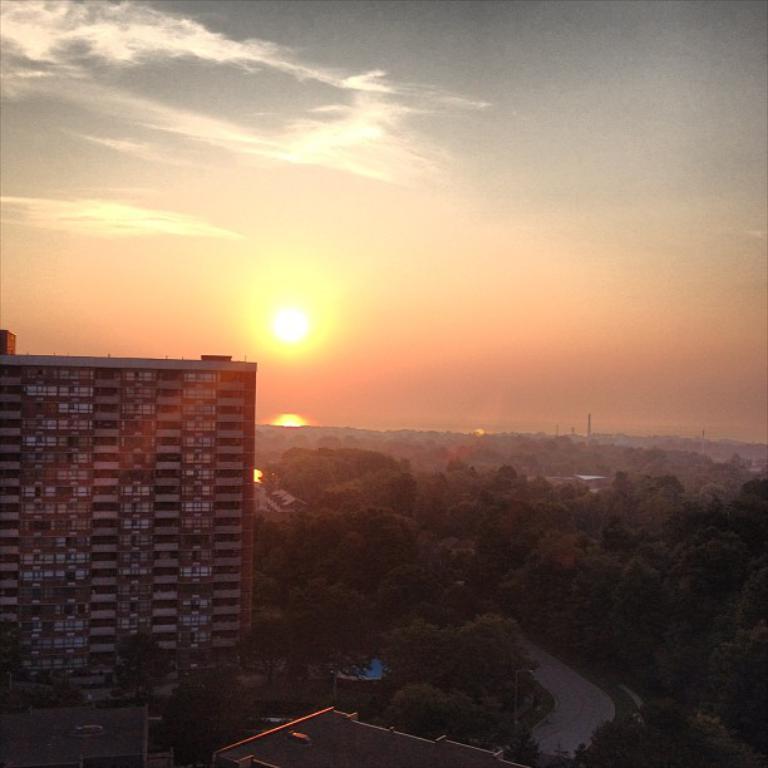Describe this image in one or two sentences. This image is taken during the sunrise. In this image we can see that there is a tall building on the left side and there are trees on the right side. At the top there is sky. In the middle there is a sun. At the bottom there is a road in the middle. 